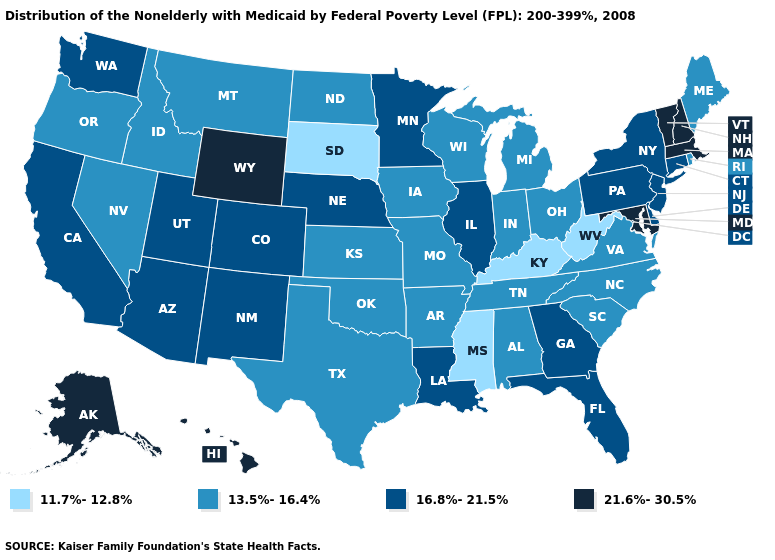Is the legend a continuous bar?
Short answer required. No. Which states have the lowest value in the MidWest?
Keep it brief. South Dakota. Name the states that have a value in the range 13.5%-16.4%?
Give a very brief answer. Alabama, Arkansas, Idaho, Indiana, Iowa, Kansas, Maine, Michigan, Missouri, Montana, Nevada, North Carolina, North Dakota, Ohio, Oklahoma, Oregon, Rhode Island, South Carolina, Tennessee, Texas, Virginia, Wisconsin. What is the highest value in the USA?
Quick response, please. 21.6%-30.5%. What is the highest value in states that border Massachusetts?
Quick response, please. 21.6%-30.5%. Which states hav the highest value in the Northeast?
Write a very short answer. Massachusetts, New Hampshire, Vermont. What is the value of Nebraska?
Short answer required. 16.8%-21.5%. Name the states that have a value in the range 13.5%-16.4%?
Concise answer only. Alabama, Arkansas, Idaho, Indiana, Iowa, Kansas, Maine, Michigan, Missouri, Montana, Nevada, North Carolina, North Dakota, Ohio, Oklahoma, Oregon, Rhode Island, South Carolina, Tennessee, Texas, Virginia, Wisconsin. Which states have the highest value in the USA?
Answer briefly. Alaska, Hawaii, Maryland, Massachusetts, New Hampshire, Vermont, Wyoming. Name the states that have a value in the range 11.7%-12.8%?
Quick response, please. Kentucky, Mississippi, South Dakota, West Virginia. Among the states that border Nebraska , which have the highest value?
Give a very brief answer. Wyoming. Name the states that have a value in the range 13.5%-16.4%?
Concise answer only. Alabama, Arkansas, Idaho, Indiana, Iowa, Kansas, Maine, Michigan, Missouri, Montana, Nevada, North Carolina, North Dakota, Ohio, Oklahoma, Oregon, Rhode Island, South Carolina, Tennessee, Texas, Virginia, Wisconsin. What is the value of North Carolina?
Be succinct. 13.5%-16.4%. Among the states that border South Carolina , does Georgia have the highest value?
Quick response, please. Yes. Among the states that border South Carolina , does Georgia have the highest value?
Short answer required. Yes. 